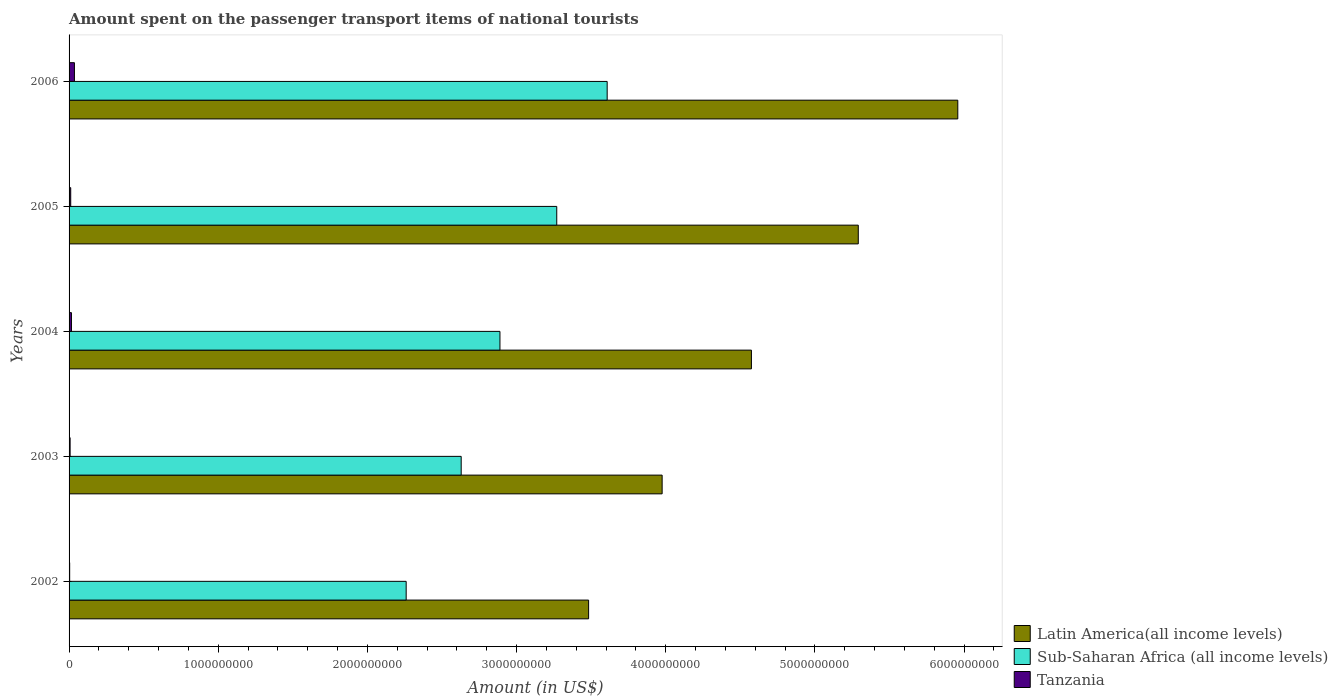How many different coloured bars are there?
Your response must be concise. 3. Are the number of bars per tick equal to the number of legend labels?
Your answer should be very brief. Yes. How many bars are there on the 4th tick from the top?
Offer a terse response. 3. What is the amount spent on the passenger transport items of national tourists in Tanzania in 2004?
Ensure brevity in your answer.  1.60e+07. Across all years, what is the maximum amount spent on the passenger transport items of national tourists in Latin America(all income levels)?
Provide a short and direct response. 5.96e+09. What is the total amount spent on the passenger transport items of national tourists in Tanzania in the graph?
Provide a succinct answer. 7.40e+07. What is the difference between the amount spent on the passenger transport items of national tourists in Latin America(all income levels) in 2004 and that in 2005?
Make the answer very short. -7.16e+08. What is the difference between the amount spent on the passenger transport items of national tourists in Tanzania in 2004 and the amount spent on the passenger transport items of national tourists in Latin America(all income levels) in 2005?
Provide a succinct answer. -5.27e+09. What is the average amount spent on the passenger transport items of national tourists in Sub-Saharan Africa (all income levels) per year?
Your answer should be very brief. 2.93e+09. In the year 2002, what is the difference between the amount spent on the passenger transport items of national tourists in Latin America(all income levels) and amount spent on the passenger transport items of national tourists in Sub-Saharan Africa (all income levels)?
Provide a short and direct response. 1.22e+09. What is the ratio of the amount spent on the passenger transport items of national tourists in Tanzania in 2004 to that in 2005?
Ensure brevity in your answer.  1.45. Is the amount spent on the passenger transport items of national tourists in Sub-Saharan Africa (all income levels) in 2003 less than that in 2006?
Offer a terse response. Yes. What is the difference between the highest and the second highest amount spent on the passenger transport items of national tourists in Latin America(all income levels)?
Offer a terse response. 6.67e+08. What is the difference between the highest and the lowest amount spent on the passenger transport items of national tourists in Sub-Saharan Africa (all income levels)?
Offer a very short reply. 1.35e+09. In how many years, is the amount spent on the passenger transport items of national tourists in Latin America(all income levels) greater than the average amount spent on the passenger transport items of national tourists in Latin America(all income levels) taken over all years?
Provide a short and direct response. 2. Is the sum of the amount spent on the passenger transport items of national tourists in Latin America(all income levels) in 2004 and 2005 greater than the maximum amount spent on the passenger transport items of national tourists in Sub-Saharan Africa (all income levels) across all years?
Provide a short and direct response. Yes. What does the 2nd bar from the top in 2004 represents?
Make the answer very short. Sub-Saharan Africa (all income levels). What does the 1st bar from the bottom in 2005 represents?
Make the answer very short. Latin America(all income levels). Is it the case that in every year, the sum of the amount spent on the passenger transport items of national tourists in Tanzania and amount spent on the passenger transport items of national tourists in Sub-Saharan Africa (all income levels) is greater than the amount spent on the passenger transport items of national tourists in Latin America(all income levels)?
Your answer should be very brief. No. How many bars are there?
Offer a terse response. 15. Are the values on the major ticks of X-axis written in scientific E-notation?
Offer a very short reply. No. Where does the legend appear in the graph?
Offer a terse response. Bottom right. What is the title of the graph?
Your answer should be very brief. Amount spent on the passenger transport items of national tourists. Does "New Caledonia" appear as one of the legend labels in the graph?
Your answer should be compact. No. What is the label or title of the Y-axis?
Provide a succinct answer. Years. What is the Amount (in US$) of Latin America(all income levels) in 2002?
Provide a short and direct response. 3.48e+09. What is the Amount (in US$) of Sub-Saharan Africa (all income levels) in 2002?
Make the answer very short. 2.26e+09. What is the Amount (in US$) of Tanzania in 2002?
Keep it short and to the point. 4.00e+06. What is the Amount (in US$) in Latin America(all income levels) in 2003?
Provide a short and direct response. 3.98e+09. What is the Amount (in US$) of Sub-Saharan Africa (all income levels) in 2003?
Provide a short and direct response. 2.63e+09. What is the Amount (in US$) of Latin America(all income levels) in 2004?
Your answer should be very brief. 4.57e+09. What is the Amount (in US$) of Sub-Saharan Africa (all income levels) in 2004?
Ensure brevity in your answer.  2.89e+09. What is the Amount (in US$) of Tanzania in 2004?
Give a very brief answer. 1.60e+07. What is the Amount (in US$) of Latin America(all income levels) in 2005?
Offer a very short reply. 5.29e+09. What is the Amount (in US$) of Sub-Saharan Africa (all income levels) in 2005?
Give a very brief answer. 3.27e+09. What is the Amount (in US$) of Tanzania in 2005?
Keep it short and to the point. 1.10e+07. What is the Amount (in US$) in Latin America(all income levels) in 2006?
Make the answer very short. 5.96e+09. What is the Amount (in US$) of Sub-Saharan Africa (all income levels) in 2006?
Ensure brevity in your answer.  3.61e+09. What is the Amount (in US$) of Tanzania in 2006?
Your response must be concise. 3.60e+07. Across all years, what is the maximum Amount (in US$) of Latin America(all income levels)?
Your response must be concise. 5.96e+09. Across all years, what is the maximum Amount (in US$) of Sub-Saharan Africa (all income levels)?
Provide a succinct answer. 3.61e+09. Across all years, what is the maximum Amount (in US$) in Tanzania?
Your answer should be compact. 3.60e+07. Across all years, what is the minimum Amount (in US$) of Latin America(all income levels)?
Your answer should be compact. 3.48e+09. Across all years, what is the minimum Amount (in US$) of Sub-Saharan Africa (all income levels)?
Keep it short and to the point. 2.26e+09. Across all years, what is the minimum Amount (in US$) in Tanzania?
Your answer should be very brief. 4.00e+06. What is the total Amount (in US$) of Latin America(all income levels) in the graph?
Offer a very short reply. 2.33e+1. What is the total Amount (in US$) in Sub-Saharan Africa (all income levels) in the graph?
Provide a short and direct response. 1.47e+1. What is the total Amount (in US$) in Tanzania in the graph?
Your answer should be very brief. 7.40e+07. What is the difference between the Amount (in US$) of Latin America(all income levels) in 2002 and that in 2003?
Offer a terse response. -4.93e+08. What is the difference between the Amount (in US$) in Sub-Saharan Africa (all income levels) in 2002 and that in 2003?
Keep it short and to the point. -3.69e+08. What is the difference between the Amount (in US$) of Latin America(all income levels) in 2002 and that in 2004?
Your answer should be compact. -1.09e+09. What is the difference between the Amount (in US$) of Sub-Saharan Africa (all income levels) in 2002 and that in 2004?
Make the answer very short. -6.29e+08. What is the difference between the Amount (in US$) in Tanzania in 2002 and that in 2004?
Give a very brief answer. -1.20e+07. What is the difference between the Amount (in US$) in Latin America(all income levels) in 2002 and that in 2005?
Offer a very short reply. -1.81e+09. What is the difference between the Amount (in US$) in Sub-Saharan Africa (all income levels) in 2002 and that in 2005?
Your answer should be compact. -1.01e+09. What is the difference between the Amount (in US$) in Tanzania in 2002 and that in 2005?
Provide a short and direct response. -7.00e+06. What is the difference between the Amount (in US$) in Latin America(all income levels) in 2002 and that in 2006?
Your answer should be very brief. -2.47e+09. What is the difference between the Amount (in US$) of Sub-Saharan Africa (all income levels) in 2002 and that in 2006?
Provide a succinct answer. -1.35e+09. What is the difference between the Amount (in US$) in Tanzania in 2002 and that in 2006?
Offer a terse response. -3.20e+07. What is the difference between the Amount (in US$) in Latin America(all income levels) in 2003 and that in 2004?
Offer a terse response. -5.99e+08. What is the difference between the Amount (in US$) of Sub-Saharan Africa (all income levels) in 2003 and that in 2004?
Give a very brief answer. -2.60e+08. What is the difference between the Amount (in US$) in Tanzania in 2003 and that in 2004?
Make the answer very short. -9.00e+06. What is the difference between the Amount (in US$) of Latin America(all income levels) in 2003 and that in 2005?
Your answer should be very brief. -1.31e+09. What is the difference between the Amount (in US$) in Sub-Saharan Africa (all income levels) in 2003 and that in 2005?
Offer a terse response. -6.41e+08. What is the difference between the Amount (in US$) of Latin America(all income levels) in 2003 and that in 2006?
Keep it short and to the point. -1.98e+09. What is the difference between the Amount (in US$) of Sub-Saharan Africa (all income levels) in 2003 and that in 2006?
Offer a very short reply. -9.79e+08. What is the difference between the Amount (in US$) of Tanzania in 2003 and that in 2006?
Give a very brief answer. -2.90e+07. What is the difference between the Amount (in US$) of Latin America(all income levels) in 2004 and that in 2005?
Provide a short and direct response. -7.16e+08. What is the difference between the Amount (in US$) in Sub-Saharan Africa (all income levels) in 2004 and that in 2005?
Keep it short and to the point. -3.81e+08. What is the difference between the Amount (in US$) in Latin America(all income levels) in 2004 and that in 2006?
Keep it short and to the point. -1.38e+09. What is the difference between the Amount (in US$) of Sub-Saharan Africa (all income levels) in 2004 and that in 2006?
Give a very brief answer. -7.19e+08. What is the difference between the Amount (in US$) in Tanzania in 2004 and that in 2006?
Your answer should be compact. -2.00e+07. What is the difference between the Amount (in US$) in Latin America(all income levels) in 2005 and that in 2006?
Your answer should be very brief. -6.67e+08. What is the difference between the Amount (in US$) in Sub-Saharan Africa (all income levels) in 2005 and that in 2006?
Provide a succinct answer. -3.38e+08. What is the difference between the Amount (in US$) in Tanzania in 2005 and that in 2006?
Provide a succinct answer. -2.50e+07. What is the difference between the Amount (in US$) of Latin America(all income levels) in 2002 and the Amount (in US$) of Sub-Saharan Africa (all income levels) in 2003?
Ensure brevity in your answer.  8.54e+08. What is the difference between the Amount (in US$) in Latin America(all income levels) in 2002 and the Amount (in US$) in Tanzania in 2003?
Offer a very short reply. 3.48e+09. What is the difference between the Amount (in US$) in Sub-Saharan Africa (all income levels) in 2002 and the Amount (in US$) in Tanzania in 2003?
Offer a very short reply. 2.25e+09. What is the difference between the Amount (in US$) in Latin America(all income levels) in 2002 and the Amount (in US$) in Sub-Saharan Africa (all income levels) in 2004?
Offer a terse response. 5.94e+08. What is the difference between the Amount (in US$) in Latin America(all income levels) in 2002 and the Amount (in US$) in Tanzania in 2004?
Offer a terse response. 3.47e+09. What is the difference between the Amount (in US$) in Sub-Saharan Africa (all income levels) in 2002 and the Amount (in US$) in Tanzania in 2004?
Make the answer very short. 2.24e+09. What is the difference between the Amount (in US$) in Latin America(all income levels) in 2002 and the Amount (in US$) in Sub-Saharan Africa (all income levels) in 2005?
Your response must be concise. 2.13e+08. What is the difference between the Amount (in US$) in Latin America(all income levels) in 2002 and the Amount (in US$) in Tanzania in 2005?
Offer a very short reply. 3.47e+09. What is the difference between the Amount (in US$) in Sub-Saharan Africa (all income levels) in 2002 and the Amount (in US$) in Tanzania in 2005?
Your response must be concise. 2.25e+09. What is the difference between the Amount (in US$) in Latin America(all income levels) in 2002 and the Amount (in US$) in Sub-Saharan Africa (all income levels) in 2006?
Your answer should be very brief. -1.24e+08. What is the difference between the Amount (in US$) of Latin America(all income levels) in 2002 and the Amount (in US$) of Tanzania in 2006?
Offer a terse response. 3.45e+09. What is the difference between the Amount (in US$) in Sub-Saharan Africa (all income levels) in 2002 and the Amount (in US$) in Tanzania in 2006?
Offer a very short reply. 2.22e+09. What is the difference between the Amount (in US$) of Latin America(all income levels) in 2003 and the Amount (in US$) of Sub-Saharan Africa (all income levels) in 2004?
Your answer should be very brief. 1.09e+09. What is the difference between the Amount (in US$) in Latin America(all income levels) in 2003 and the Amount (in US$) in Tanzania in 2004?
Offer a very short reply. 3.96e+09. What is the difference between the Amount (in US$) in Sub-Saharan Africa (all income levels) in 2003 and the Amount (in US$) in Tanzania in 2004?
Make the answer very short. 2.61e+09. What is the difference between the Amount (in US$) in Latin America(all income levels) in 2003 and the Amount (in US$) in Sub-Saharan Africa (all income levels) in 2005?
Provide a short and direct response. 7.06e+08. What is the difference between the Amount (in US$) of Latin America(all income levels) in 2003 and the Amount (in US$) of Tanzania in 2005?
Ensure brevity in your answer.  3.96e+09. What is the difference between the Amount (in US$) in Sub-Saharan Africa (all income levels) in 2003 and the Amount (in US$) in Tanzania in 2005?
Your answer should be compact. 2.62e+09. What is the difference between the Amount (in US$) of Latin America(all income levels) in 2003 and the Amount (in US$) of Sub-Saharan Africa (all income levels) in 2006?
Provide a succinct answer. 3.68e+08. What is the difference between the Amount (in US$) in Latin America(all income levels) in 2003 and the Amount (in US$) in Tanzania in 2006?
Provide a succinct answer. 3.94e+09. What is the difference between the Amount (in US$) of Sub-Saharan Africa (all income levels) in 2003 and the Amount (in US$) of Tanzania in 2006?
Keep it short and to the point. 2.59e+09. What is the difference between the Amount (in US$) of Latin America(all income levels) in 2004 and the Amount (in US$) of Sub-Saharan Africa (all income levels) in 2005?
Make the answer very short. 1.30e+09. What is the difference between the Amount (in US$) of Latin America(all income levels) in 2004 and the Amount (in US$) of Tanzania in 2005?
Offer a terse response. 4.56e+09. What is the difference between the Amount (in US$) of Sub-Saharan Africa (all income levels) in 2004 and the Amount (in US$) of Tanzania in 2005?
Provide a succinct answer. 2.88e+09. What is the difference between the Amount (in US$) in Latin America(all income levels) in 2004 and the Amount (in US$) in Sub-Saharan Africa (all income levels) in 2006?
Offer a terse response. 9.67e+08. What is the difference between the Amount (in US$) in Latin America(all income levels) in 2004 and the Amount (in US$) in Tanzania in 2006?
Give a very brief answer. 4.54e+09. What is the difference between the Amount (in US$) in Sub-Saharan Africa (all income levels) in 2004 and the Amount (in US$) in Tanzania in 2006?
Provide a succinct answer. 2.85e+09. What is the difference between the Amount (in US$) in Latin America(all income levels) in 2005 and the Amount (in US$) in Sub-Saharan Africa (all income levels) in 2006?
Provide a short and direct response. 1.68e+09. What is the difference between the Amount (in US$) in Latin America(all income levels) in 2005 and the Amount (in US$) in Tanzania in 2006?
Your answer should be compact. 5.25e+09. What is the difference between the Amount (in US$) of Sub-Saharan Africa (all income levels) in 2005 and the Amount (in US$) of Tanzania in 2006?
Ensure brevity in your answer.  3.23e+09. What is the average Amount (in US$) of Latin America(all income levels) per year?
Provide a short and direct response. 4.66e+09. What is the average Amount (in US$) of Sub-Saharan Africa (all income levels) per year?
Provide a succinct answer. 2.93e+09. What is the average Amount (in US$) of Tanzania per year?
Give a very brief answer. 1.48e+07. In the year 2002, what is the difference between the Amount (in US$) in Latin America(all income levels) and Amount (in US$) in Sub-Saharan Africa (all income levels)?
Your answer should be compact. 1.22e+09. In the year 2002, what is the difference between the Amount (in US$) of Latin America(all income levels) and Amount (in US$) of Tanzania?
Provide a succinct answer. 3.48e+09. In the year 2002, what is the difference between the Amount (in US$) in Sub-Saharan Africa (all income levels) and Amount (in US$) in Tanzania?
Offer a terse response. 2.26e+09. In the year 2003, what is the difference between the Amount (in US$) of Latin America(all income levels) and Amount (in US$) of Sub-Saharan Africa (all income levels)?
Your answer should be compact. 1.35e+09. In the year 2003, what is the difference between the Amount (in US$) of Latin America(all income levels) and Amount (in US$) of Tanzania?
Offer a very short reply. 3.97e+09. In the year 2003, what is the difference between the Amount (in US$) of Sub-Saharan Africa (all income levels) and Amount (in US$) of Tanzania?
Keep it short and to the point. 2.62e+09. In the year 2004, what is the difference between the Amount (in US$) of Latin America(all income levels) and Amount (in US$) of Sub-Saharan Africa (all income levels)?
Ensure brevity in your answer.  1.69e+09. In the year 2004, what is the difference between the Amount (in US$) in Latin America(all income levels) and Amount (in US$) in Tanzania?
Offer a terse response. 4.56e+09. In the year 2004, what is the difference between the Amount (in US$) of Sub-Saharan Africa (all income levels) and Amount (in US$) of Tanzania?
Your answer should be very brief. 2.87e+09. In the year 2005, what is the difference between the Amount (in US$) of Latin America(all income levels) and Amount (in US$) of Sub-Saharan Africa (all income levels)?
Your response must be concise. 2.02e+09. In the year 2005, what is the difference between the Amount (in US$) of Latin America(all income levels) and Amount (in US$) of Tanzania?
Provide a succinct answer. 5.28e+09. In the year 2005, what is the difference between the Amount (in US$) of Sub-Saharan Africa (all income levels) and Amount (in US$) of Tanzania?
Offer a very short reply. 3.26e+09. In the year 2006, what is the difference between the Amount (in US$) in Latin America(all income levels) and Amount (in US$) in Sub-Saharan Africa (all income levels)?
Offer a very short reply. 2.35e+09. In the year 2006, what is the difference between the Amount (in US$) of Latin America(all income levels) and Amount (in US$) of Tanzania?
Offer a very short reply. 5.92e+09. In the year 2006, what is the difference between the Amount (in US$) in Sub-Saharan Africa (all income levels) and Amount (in US$) in Tanzania?
Your answer should be compact. 3.57e+09. What is the ratio of the Amount (in US$) in Latin America(all income levels) in 2002 to that in 2003?
Your answer should be compact. 0.88. What is the ratio of the Amount (in US$) in Sub-Saharan Africa (all income levels) in 2002 to that in 2003?
Ensure brevity in your answer.  0.86. What is the ratio of the Amount (in US$) of Latin America(all income levels) in 2002 to that in 2004?
Offer a very short reply. 0.76. What is the ratio of the Amount (in US$) in Sub-Saharan Africa (all income levels) in 2002 to that in 2004?
Your response must be concise. 0.78. What is the ratio of the Amount (in US$) of Tanzania in 2002 to that in 2004?
Your response must be concise. 0.25. What is the ratio of the Amount (in US$) of Latin America(all income levels) in 2002 to that in 2005?
Provide a short and direct response. 0.66. What is the ratio of the Amount (in US$) in Sub-Saharan Africa (all income levels) in 2002 to that in 2005?
Give a very brief answer. 0.69. What is the ratio of the Amount (in US$) in Tanzania in 2002 to that in 2005?
Keep it short and to the point. 0.36. What is the ratio of the Amount (in US$) of Latin America(all income levels) in 2002 to that in 2006?
Your answer should be compact. 0.58. What is the ratio of the Amount (in US$) in Sub-Saharan Africa (all income levels) in 2002 to that in 2006?
Your answer should be very brief. 0.63. What is the ratio of the Amount (in US$) in Latin America(all income levels) in 2003 to that in 2004?
Ensure brevity in your answer.  0.87. What is the ratio of the Amount (in US$) in Sub-Saharan Africa (all income levels) in 2003 to that in 2004?
Ensure brevity in your answer.  0.91. What is the ratio of the Amount (in US$) of Tanzania in 2003 to that in 2004?
Offer a terse response. 0.44. What is the ratio of the Amount (in US$) in Latin America(all income levels) in 2003 to that in 2005?
Your response must be concise. 0.75. What is the ratio of the Amount (in US$) in Sub-Saharan Africa (all income levels) in 2003 to that in 2005?
Make the answer very short. 0.8. What is the ratio of the Amount (in US$) of Tanzania in 2003 to that in 2005?
Give a very brief answer. 0.64. What is the ratio of the Amount (in US$) in Latin America(all income levels) in 2003 to that in 2006?
Your answer should be compact. 0.67. What is the ratio of the Amount (in US$) of Sub-Saharan Africa (all income levels) in 2003 to that in 2006?
Offer a very short reply. 0.73. What is the ratio of the Amount (in US$) in Tanzania in 2003 to that in 2006?
Provide a short and direct response. 0.19. What is the ratio of the Amount (in US$) in Latin America(all income levels) in 2004 to that in 2005?
Keep it short and to the point. 0.86. What is the ratio of the Amount (in US$) in Sub-Saharan Africa (all income levels) in 2004 to that in 2005?
Your answer should be compact. 0.88. What is the ratio of the Amount (in US$) of Tanzania in 2004 to that in 2005?
Ensure brevity in your answer.  1.45. What is the ratio of the Amount (in US$) in Latin America(all income levels) in 2004 to that in 2006?
Ensure brevity in your answer.  0.77. What is the ratio of the Amount (in US$) of Sub-Saharan Africa (all income levels) in 2004 to that in 2006?
Make the answer very short. 0.8. What is the ratio of the Amount (in US$) of Tanzania in 2004 to that in 2006?
Provide a short and direct response. 0.44. What is the ratio of the Amount (in US$) in Latin America(all income levels) in 2005 to that in 2006?
Give a very brief answer. 0.89. What is the ratio of the Amount (in US$) of Sub-Saharan Africa (all income levels) in 2005 to that in 2006?
Keep it short and to the point. 0.91. What is the ratio of the Amount (in US$) in Tanzania in 2005 to that in 2006?
Ensure brevity in your answer.  0.31. What is the difference between the highest and the second highest Amount (in US$) in Latin America(all income levels)?
Give a very brief answer. 6.67e+08. What is the difference between the highest and the second highest Amount (in US$) in Sub-Saharan Africa (all income levels)?
Provide a short and direct response. 3.38e+08. What is the difference between the highest and the lowest Amount (in US$) in Latin America(all income levels)?
Make the answer very short. 2.47e+09. What is the difference between the highest and the lowest Amount (in US$) of Sub-Saharan Africa (all income levels)?
Keep it short and to the point. 1.35e+09. What is the difference between the highest and the lowest Amount (in US$) in Tanzania?
Keep it short and to the point. 3.20e+07. 